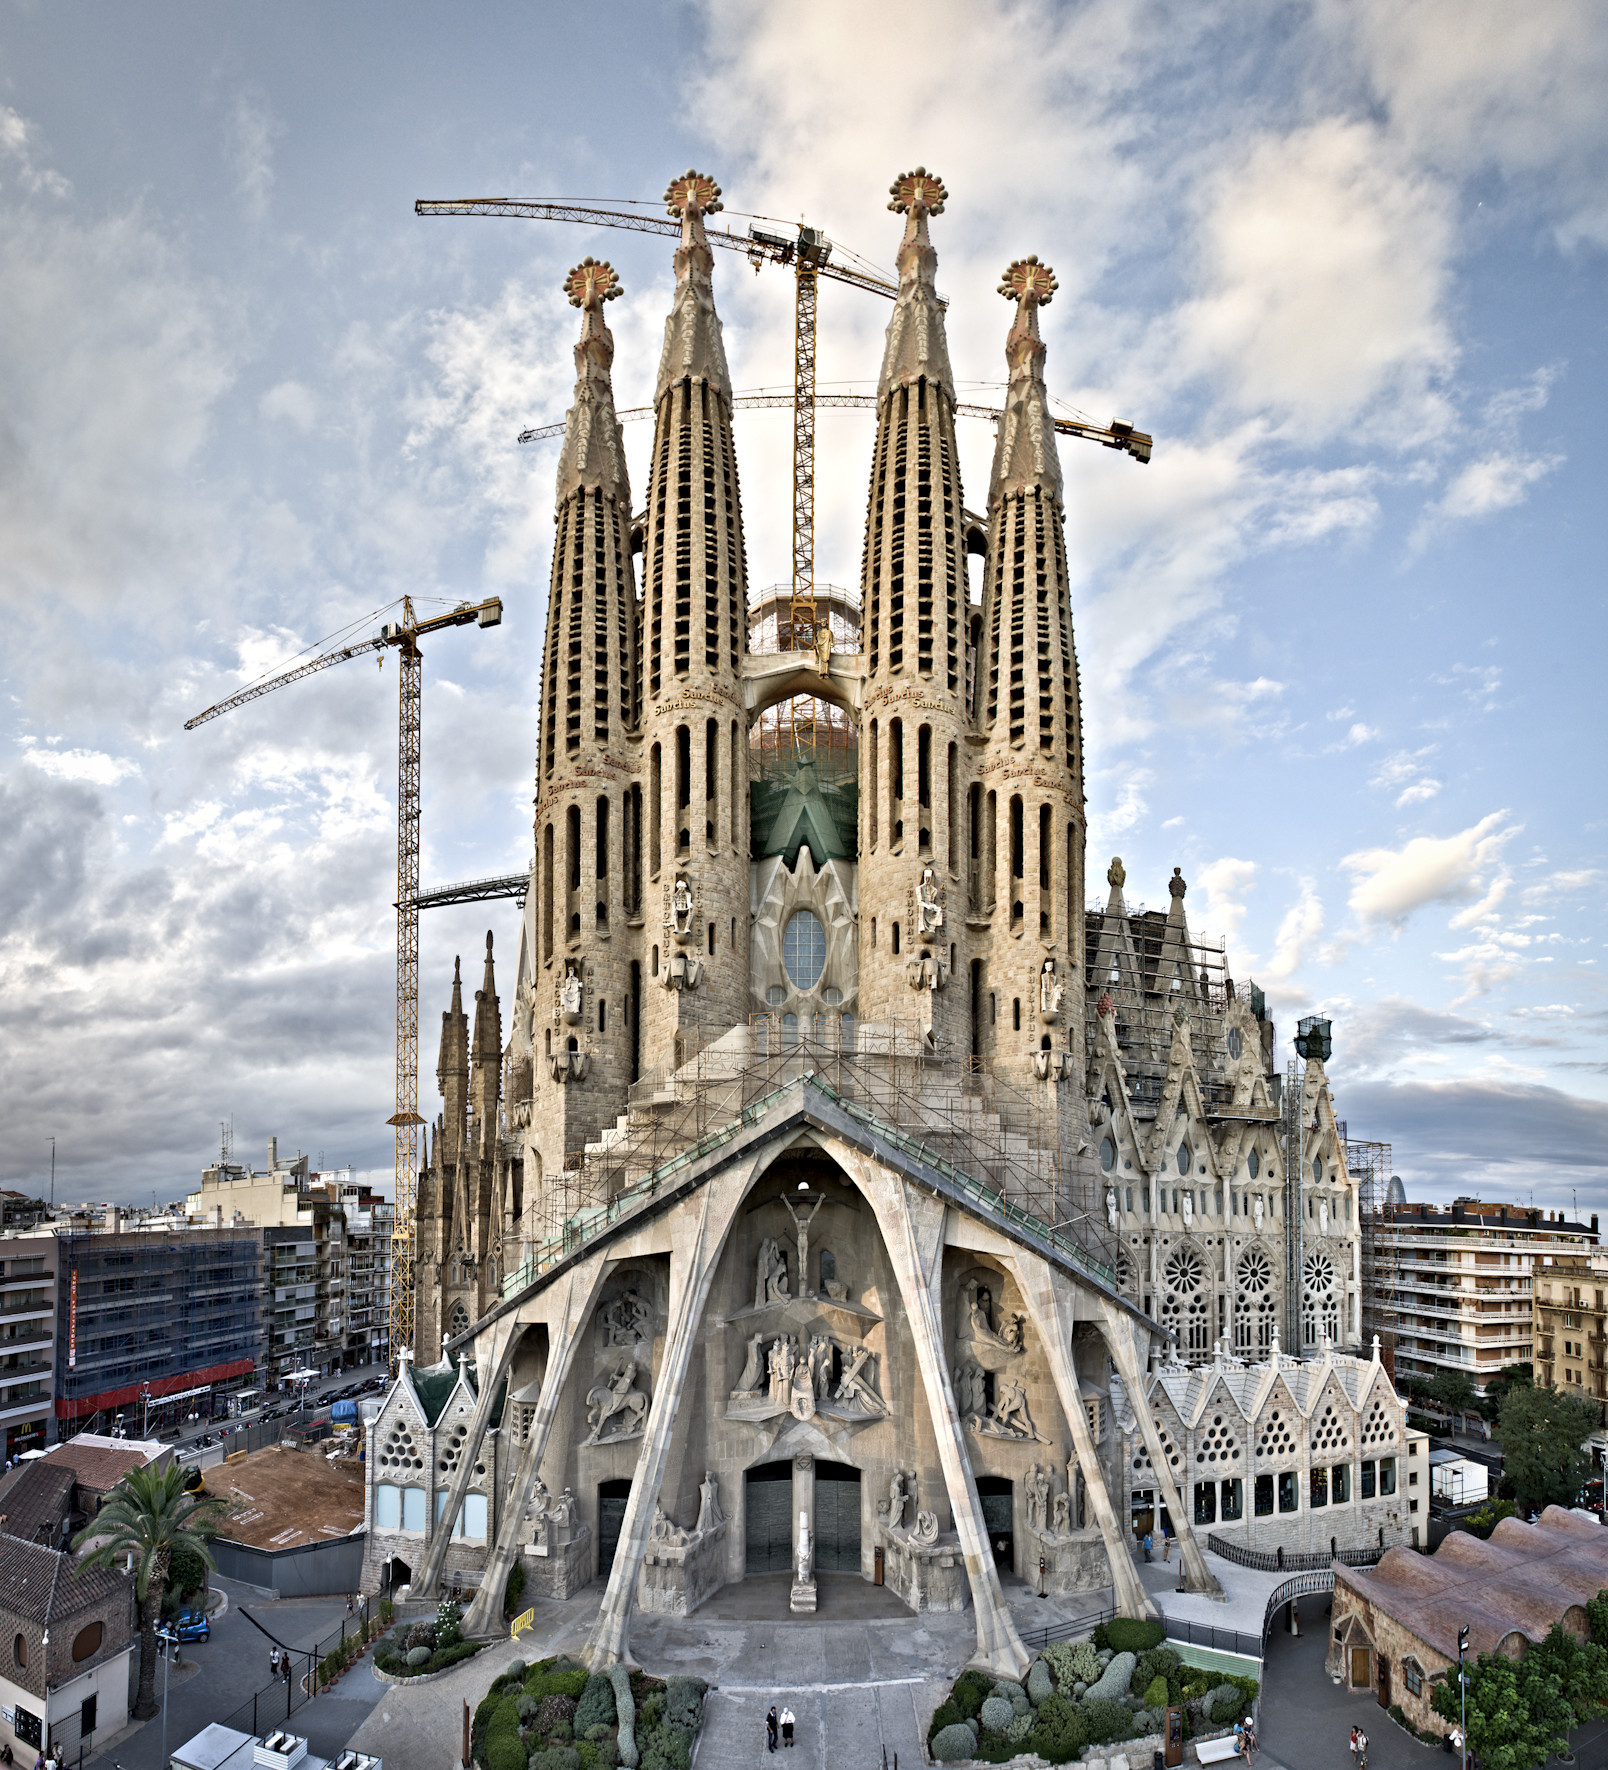Imagine a fictional story where the Sagrada Familia becomes a portal to another world. What would that world be like? In a fictional story, the Sagrada Familia could be a mystical portal to an enchanted world. This world might be a lush, magical realm where nature and architecture intertwine seamlessly. Towering trees with crystalline leaves would form natural cathedrals, and rivers of liquid light would flow through the landscape. Mythical creatures like winged lions and sentient stone guardians might inhabit this realm, each one echoing the artistic motifs found in the Sagrada Familia.

The inhabitants of this world would be a society of artisans and dreamers, continuously building and enhancing their surroundings in a harmonious blend of craftsmanship and magic. Visitors to this realm would find themselves inspired and awed, carrying the essence of creativity and unity back to their own world. 